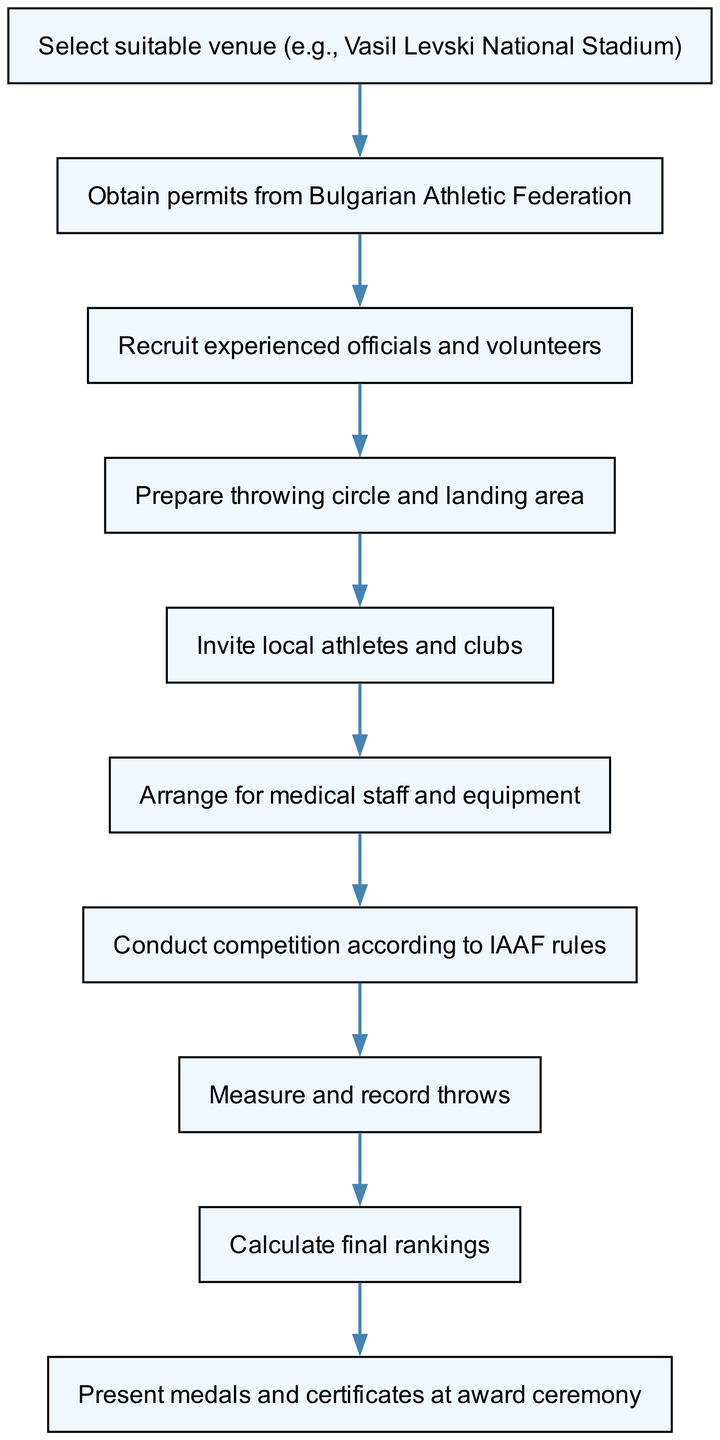What is the first step in organizing the competition? The first step in the diagram is to "Select suitable venue (e.g., Vasil Levski National Stadium)", as indicated in the first node.
Answer: Select suitable venue (e.g., Vasil Levski National Stadium) How many nodes are there in the diagram? By counting the elements listed in the diagram, there are a total of 10 nodes representing various steps in the competition organization process.
Answer: 10 What is the step following "Obtain permits from Bulgarian Athletic Federation"? The next step that follows "Obtain permits from Bulgarian Athletic Federation" in the flow is "Recruit experienced officials and volunteers", shown in the connection from node 2 to node 3.
Answer: Recruit experienced officials and volunteers How is medical staff related to the competition? "Arrange for medical staff and equipment" is a step that follows "Invite local athletes and clubs", indicating its relation as necessary for ensuring the safety and health of participants during the event.
Answer: Arrange for medical staff and equipment What is the last action before the award ceremony? The action just before the award ceremony is to "Calculate final rankings", as the diagram shows that all results must be finalized before presenting awards.
Answer: Calculate final rankings If the competition is conducted according to the rules, what should be measured next? Once the competition is conducted according to IAAF rules, the next immediate action is to "Measure and record throws" as per the sequential flow outlined in the diagram.
Answer: Measure and record throws How many edges connect the nodes in the diagram? Counting the connections defined in the diagram, there are a total of 9 edges that link the various steps representing the flow from one action to the next.
Answer: 9 What is the connection between measuring throws and presenting awards? After "Measure and record throws", the next step is to "Calculate final rankings", which ultimately leads to the step of "Present medals and certificates at award ceremony", establishing a clear connection through these sequential actions.
Answer: Present medals and certificates at award ceremony 